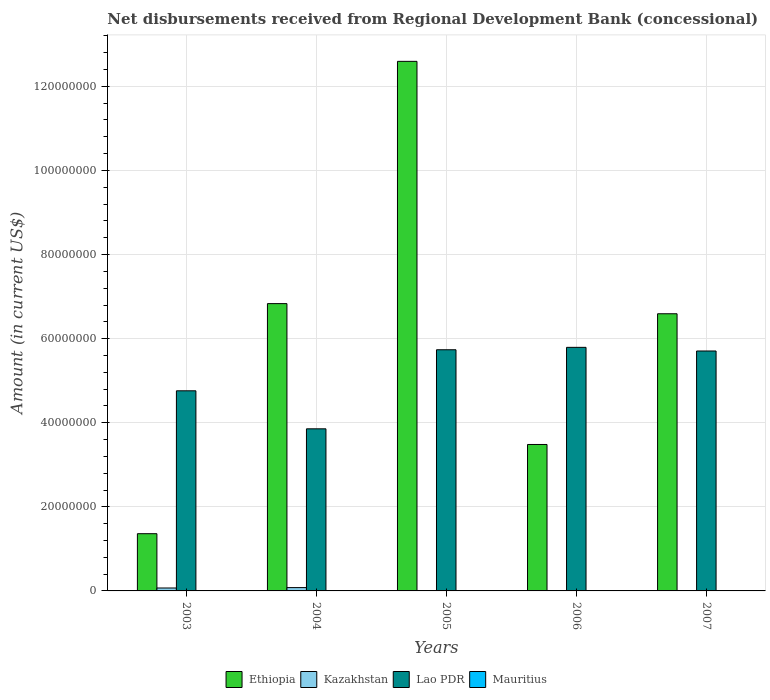How many groups of bars are there?
Provide a short and direct response. 5. Are the number of bars per tick equal to the number of legend labels?
Your answer should be very brief. No. How many bars are there on the 1st tick from the right?
Provide a succinct answer. 2. What is the label of the 2nd group of bars from the left?
Give a very brief answer. 2004. What is the amount of disbursements received from Regional Development Bank in Kazakhstan in 2005?
Your response must be concise. 9.50e+04. Across all years, what is the maximum amount of disbursements received from Regional Development Bank in Lao PDR?
Ensure brevity in your answer.  5.79e+07. Across all years, what is the minimum amount of disbursements received from Regional Development Bank in Lao PDR?
Provide a succinct answer. 3.86e+07. In which year was the amount of disbursements received from Regional Development Bank in Lao PDR maximum?
Your answer should be compact. 2006. What is the total amount of disbursements received from Regional Development Bank in Kazakhstan in the graph?
Offer a very short reply. 1.58e+06. What is the difference between the amount of disbursements received from Regional Development Bank in Lao PDR in 2003 and that in 2007?
Make the answer very short. -9.47e+06. What is the difference between the amount of disbursements received from Regional Development Bank in Mauritius in 2006 and the amount of disbursements received from Regional Development Bank in Lao PDR in 2004?
Your answer should be very brief. -3.86e+07. What is the average amount of disbursements received from Regional Development Bank in Ethiopia per year?
Make the answer very short. 6.17e+07. In the year 2003, what is the difference between the amount of disbursements received from Regional Development Bank in Ethiopia and amount of disbursements received from Regional Development Bank in Lao PDR?
Your answer should be compact. -3.40e+07. What is the ratio of the amount of disbursements received from Regional Development Bank in Kazakhstan in 2003 to that in 2005?
Offer a very short reply. 7.35. What is the difference between the highest and the second highest amount of disbursements received from Regional Development Bank in Ethiopia?
Offer a very short reply. 5.76e+07. What is the difference between the highest and the lowest amount of disbursements received from Regional Development Bank in Ethiopia?
Make the answer very short. 1.12e+08. In how many years, is the amount of disbursements received from Regional Development Bank in Mauritius greater than the average amount of disbursements received from Regional Development Bank in Mauritius taken over all years?
Your answer should be compact. 0. Are all the bars in the graph horizontal?
Provide a succinct answer. No. What is the difference between two consecutive major ticks on the Y-axis?
Provide a short and direct response. 2.00e+07. Are the values on the major ticks of Y-axis written in scientific E-notation?
Your answer should be compact. No. Does the graph contain grids?
Make the answer very short. Yes. How many legend labels are there?
Ensure brevity in your answer.  4. What is the title of the graph?
Your response must be concise. Net disbursements received from Regional Development Bank (concessional). Does "Namibia" appear as one of the legend labels in the graph?
Offer a very short reply. No. What is the label or title of the Y-axis?
Your answer should be very brief. Amount (in current US$). What is the Amount (in current US$) in Ethiopia in 2003?
Your response must be concise. 1.36e+07. What is the Amount (in current US$) of Kazakhstan in 2003?
Give a very brief answer. 6.98e+05. What is the Amount (in current US$) in Lao PDR in 2003?
Give a very brief answer. 4.76e+07. What is the Amount (in current US$) in Mauritius in 2003?
Provide a short and direct response. 0. What is the Amount (in current US$) of Ethiopia in 2004?
Make the answer very short. 6.83e+07. What is the Amount (in current US$) in Kazakhstan in 2004?
Offer a terse response. 7.91e+05. What is the Amount (in current US$) in Lao PDR in 2004?
Provide a succinct answer. 3.86e+07. What is the Amount (in current US$) in Mauritius in 2004?
Provide a succinct answer. 0. What is the Amount (in current US$) of Ethiopia in 2005?
Offer a very short reply. 1.26e+08. What is the Amount (in current US$) in Kazakhstan in 2005?
Ensure brevity in your answer.  9.50e+04. What is the Amount (in current US$) of Lao PDR in 2005?
Give a very brief answer. 5.74e+07. What is the Amount (in current US$) in Ethiopia in 2006?
Ensure brevity in your answer.  3.48e+07. What is the Amount (in current US$) of Lao PDR in 2006?
Your answer should be very brief. 5.79e+07. What is the Amount (in current US$) in Mauritius in 2006?
Provide a succinct answer. 0. What is the Amount (in current US$) in Ethiopia in 2007?
Provide a short and direct response. 6.59e+07. What is the Amount (in current US$) in Kazakhstan in 2007?
Your answer should be very brief. 0. What is the Amount (in current US$) in Lao PDR in 2007?
Offer a very short reply. 5.71e+07. What is the Amount (in current US$) of Mauritius in 2007?
Offer a terse response. 0. Across all years, what is the maximum Amount (in current US$) of Ethiopia?
Keep it short and to the point. 1.26e+08. Across all years, what is the maximum Amount (in current US$) in Kazakhstan?
Your answer should be very brief. 7.91e+05. Across all years, what is the maximum Amount (in current US$) in Lao PDR?
Give a very brief answer. 5.79e+07. Across all years, what is the minimum Amount (in current US$) in Ethiopia?
Offer a very short reply. 1.36e+07. Across all years, what is the minimum Amount (in current US$) in Kazakhstan?
Give a very brief answer. 0. Across all years, what is the minimum Amount (in current US$) of Lao PDR?
Keep it short and to the point. 3.86e+07. What is the total Amount (in current US$) in Ethiopia in the graph?
Make the answer very short. 3.09e+08. What is the total Amount (in current US$) of Kazakhstan in the graph?
Ensure brevity in your answer.  1.58e+06. What is the total Amount (in current US$) of Lao PDR in the graph?
Provide a succinct answer. 2.58e+08. What is the total Amount (in current US$) of Mauritius in the graph?
Your answer should be compact. 0. What is the difference between the Amount (in current US$) in Ethiopia in 2003 and that in 2004?
Provide a short and direct response. -5.47e+07. What is the difference between the Amount (in current US$) in Kazakhstan in 2003 and that in 2004?
Offer a very short reply. -9.30e+04. What is the difference between the Amount (in current US$) in Lao PDR in 2003 and that in 2004?
Give a very brief answer. 9.04e+06. What is the difference between the Amount (in current US$) in Ethiopia in 2003 and that in 2005?
Provide a short and direct response. -1.12e+08. What is the difference between the Amount (in current US$) in Kazakhstan in 2003 and that in 2005?
Offer a terse response. 6.03e+05. What is the difference between the Amount (in current US$) in Lao PDR in 2003 and that in 2005?
Give a very brief answer. -9.76e+06. What is the difference between the Amount (in current US$) in Ethiopia in 2003 and that in 2006?
Provide a short and direct response. -2.12e+07. What is the difference between the Amount (in current US$) of Lao PDR in 2003 and that in 2006?
Your answer should be compact. -1.03e+07. What is the difference between the Amount (in current US$) in Ethiopia in 2003 and that in 2007?
Provide a short and direct response. -5.23e+07. What is the difference between the Amount (in current US$) in Lao PDR in 2003 and that in 2007?
Provide a succinct answer. -9.47e+06. What is the difference between the Amount (in current US$) in Ethiopia in 2004 and that in 2005?
Provide a short and direct response. -5.76e+07. What is the difference between the Amount (in current US$) in Kazakhstan in 2004 and that in 2005?
Your answer should be very brief. 6.96e+05. What is the difference between the Amount (in current US$) in Lao PDR in 2004 and that in 2005?
Your answer should be very brief. -1.88e+07. What is the difference between the Amount (in current US$) in Ethiopia in 2004 and that in 2006?
Offer a terse response. 3.35e+07. What is the difference between the Amount (in current US$) of Lao PDR in 2004 and that in 2006?
Your answer should be very brief. -1.94e+07. What is the difference between the Amount (in current US$) in Ethiopia in 2004 and that in 2007?
Your answer should be compact. 2.41e+06. What is the difference between the Amount (in current US$) in Lao PDR in 2004 and that in 2007?
Give a very brief answer. -1.85e+07. What is the difference between the Amount (in current US$) of Ethiopia in 2005 and that in 2006?
Provide a succinct answer. 9.11e+07. What is the difference between the Amount (in current US$) in Lao PDR in 2005 and that in 2006?
Your answer should be compact. -5.73e+05. What is the difference between the Amount (in current US$) in Ethiopia in 2005 and that in 2007?
Offer a very short reply. 6.00e+07. What is the difference between the Amount (in current US$) in Lao PDR in 2005 and that in 2007?
Your response must be concise. 2.91e+05. What is the difference between the Amount (in current US$) of Ethiopia in 2006 and that in 2007?
Provide a short and direct response. -3.11e+07. What is the difference between the Amount (in current US$) of Lao PDR in 2006 and that in 2007?
Your answer should be compact. 8.64e+05. What is the difference between the Amount (in current US$) of Ethiopia in 2003 and the Amount (in current US$) of Kazakhstan in 2004?
Provide a short and direct response. 1.28e+07. What is the difference between the Amount (in current US$) of Ethiopia in 2003 and the Amount (in current US$) of Lao PDR in 2004?
Your response must be concise. -2.49e+07. What is the difference between the Amount (in current US$) of Kazakhstan in 2003 and the Amount (in current US$) of Lao PDR in 2004?
Offer a very short reply. -3.79e+07. What is the difference between the Amount (in current US$) of Ethiopia in 2003 and the Amount (in current US$) of Kazakhstan in 2005?
Your response must be concise. 1.35e+07. What is the difference between the Amount (in current US$) in Ethiopia in 2003 and the Amount (in current US$) in Lao PDR in 2005?
Provide a short and direct response. -4.37e+07. What is the difference between the Amount (in current US$) in Kazakhstan in 2003 and the Amount (in current US$) in Lao PDR in 2005?
Your answer should be compact. -5.67e+07. What is the difference between the Amount (in current US$) in Ethiopia in 2003 and the Amount (in current US$) in Lao PDR in 2006?
Your answer should be compact. -4.43e+07. What is the difference between the Amount (in current US$) in Kazakhstan in 2003 and the Amount (in current US$) in Lao PDR in 2006?
Your answer should be compact. -5.72e+07. What is the difference between the Amount (in current US$) in Ethiopia in 2003 and the Amount (in current US$) in Lao PDR in 2007?
Keep it short and to the point. -4.35e+07. What is the difference between the Amount (in current US$) in Kazakhstan in 2003 and the Amount (in current US$) in Lao PDR in 2007?
Offer a terse response. -5.64e+07. What is the difference between the Amount (in current US$) of Ethiopia in 2004 and the Amount (in current US$) of Kazakhstan in 2005?
Offer a terse response. 6.82e+07. What is the difference between the Amount (in current US$) of Ethiopia in 2004 and the Amount (in current US$) of Lao PDR in 2005?
Provide a succinct answer. 1.10e+07. What is the difference between the Amount (in current US$) in Kazakhstan in 2004 and the Amount (in current US$) in Lao PDR in 2005?
Give a very brief answer. -5.66e+07. What is the difference between the Amount (in current US$) in Ethiopia in 2004 and the Amount (in current US$) in Lao PDR in 2006?
Provide a succinct answer. 1.04e+07. What is the difference between the Amount (in current US$) in Kazakhstan in 2004 and the Amount (in current US$) in Lao PDR in 2006?
Keep it short and to the point. -5.71e+07. What is the difference between the Amount (in current US$) in Ethiopia in 2004 and the Amount (in current US$) in Lao PDR in 2007?
Offer a very short reply. 1.13e+07. What is the difference between the Amount (in current US$) of Kazakhstan in 2004 and the Amount (in current US$) of Lao PDR in 2007?
Give a very brief answer. -5.63e+07. What is the difference between the Amount (in current US$) of Ethiopia in 2005 and the Amount (in current US$) of Lao PDR in 2006?
Offer a very short reply. 6.80e+07. What is the difference between the Amount (in current US$) in Kazakhstan in 2005 and the Amount (in current US$) in Lao PDR in 2006?
Ensure brevity in your answer.  -5.78e+07. What is the difference between the Amount (in current US$) in Ethiopia in 2005 and the Amount (in current US$) in Lao PDR in 2007?
Your answer should be very brief. 6.89e+07. What is the difference between the Amount (in current US$) in Kazakhstan in 2005 and the Amount (in current US$) in Lao PDR in 2007?
Your answer should be very brief. -5.70e+07. What is the difference between the Amount (in current US$) in Ethiopia in 2006 and the Amount (in current US$) in Lao PDR in 2007?
Offer a very short reply. -2.22e+07. What is the average Amount (in current US$) of Ethiopia per year?
Your answer should be compact. 6.17e+07. What is the average Amount (in current US$) of Kazakhstan per year?
Your response must be concise. 3.17e+05. What is the average Amount (in current US$) in Lao PDR per year?
Give a very brief answer. 5.17e+07. What is the average Amount (in current US$) of Mauritius per year?
Your answer should be very brief. 0. In the year 2003, what is the difference between the Amount (in current US$) in Ethiopia and Amount (in current US$) in Kazakhstan?
Your answer should be compact. 1.29e+07. In the year 2003, what is the difference between the Amount (in current US$) of Ethiopia and Amount (in current US$) of Lao PDR?
Your answer should be very brief. -3.40e+07. In the year 2003, what is the difference between the Amount (in current US$) of Kazakhstan and Amount (in current US$) of Lao PDR?
Make the answer very short. -4.69e+07. In the year 2004, what is the difference between the Amount (in current US$) in Ethiopia and Amount (in current US$) in Kazakhstan?
Provide a short and direct response. 6.75e+07. In the year 2004, what is the difference between the Amount (in current US$) of Ethiopia and Amount (in current US$) of Lao PDR?
Keep it short and to the point. 2.98e+07. In the year 2004, what is the difference between the Amount (in current US$) in Kazakhstan and Amount (in current US$) in Lao PDR?
Provide a short and direct response. -3.78e+07. In the year 2005, what is the difference between the Amount (in current US$) in Ethiopia and Amount (in current US$) in Kazakhstan?
Give a very brief answer. 1.26e+08. In the year 2005, what is the difference between the Amount (in current US$) of Ethiopia and Amount (in current US$) of Lao PDR?
Make the answer very short. 6.86e+07. In the year 2005, what is the difference between the Amount (in current US$) in Kazakhstan and Amount (in current US$) in Lao PDR?
Ensure brevity in your answer.  -5.73e+07. In the year 2006, what is the difference between the Amount (in current US$) of Ethiopia and Amount (in current US$) of Lao PDR?
Provide a succinct answer. -2.31e+07. In the year 2007, what is the difference between the Amount (in current US$) in Ethiopia and Amount (in current US$) in Lao PDR?
Your answer should be compact. 8.85e+06. What is the ratio of the Amount (in current US$) of Ethiopia in 2003 to that in 2004?
Provide a short and direct response. 0.2. What is the ratio of the Amount (in current US$) in Kazakhstan in 2003 to that in 2004?
Offer a very short reply. 0.88. What is the ratio of the Amount (in current US$) of Lao PDR in 2003 to that in 2004?
Your response must be concise. 1.23. What is the ratio of the Amount (in current US$) in Ethiopia in 2003 to that in 2005?
Offer a terse response. 0.11. What is the ratio of the Amount (in current US$) in Kazakhstan in 2003 to that in 2005?
Make the answer very short. 7.35. What is the ratio of the Amount (in current US$) of Lao PDR in 2003 to that in 2005?
Provide a succinct answer. 0.83. What is the ratio of the Amount (in current US$) of Ethiopia in 2003 to that in 2006?
Your answer should be compact. 0.39. What is the ratio of the Amount (in current US$) in Lao PDR in 2003 to that in 2006?
Your answer should be compact. 0.82. What is the ratio of the Amount (in current US$) in Ethiopia in 2003 to that in 2007?
Make the answer very short. 0.21. What is the ratio of the Amount (in current US$) in Lao PDR in 2003 to that in 2007?
Keep it short and to the point. 0.83. What is the ratio of the Amount (in current US$) in Ethiopia in 2004 to that in 2005?
Provide a short and direct response. 0.54. What is the ratio of the Amount (in current US$) of Kazakhstan in 2004 to that in 2005?
Make the answer very short. 8.33. What is the ratio of the Amount (in current US$) of Lao PDR in 2004 to that in 2005?
Your response must be concise. 0.67. What is the ratio of the Amount (in current US$) of Ethiopia in 2004 to that in 2006?
Ensure brevity in your answer.  1.96. What is the ratio of the Amount (in current US$) in Lao PDR in 2004 to that in 2006?
Keep it short and to the point. 0.67. What is the ratio of the Amount (in current US$) in Ethiopia in 2004 to that in 2007?
Offer a terse response. 1.04. What is the ratio of the Amount (in current US$) in Lao PDR in 2004 to that in 2007?
Ensure brevity in your answer.  0.68. What is the ratio of the Amount (in current US$) of Ethiopia in 2005 to that in 2006?
Offer a very short reply. 3.62. What is the ratio of the Amount (in current US$) of Lao PDR in 2005 to that in 2006?
Offer a very short reply. 0.99. What is the ratio of the Amount (in current US$) in Ethiopia in 2005 to that in 2007?
Give a very brief answer. 1.91. What is the ratio of the Amount (in current US$) of Lao PDR in 2005 to that in 2007?
Ensure brevity in your answer.  1.01. What is the ratio of the Amount (in current US$) in Ethiopia in 2006 to that in 2007?
Provide a short and direct response. 0.53. What is the ratio of the Amount (in current US$) of Lao PDR in 2006 to that in 2007?
Keep it short and to the point. 1.02. What is the difference between the highest and the second highest Amount (in current US$) in Ethiopia?
Offer a terse response. 5.76e+07. What is the difference between the highest and the second highest Amount (in current US$) of Kazakhstan?
Give a very brief answer. 9.30e+04. What is the difference between the highest and the second highest Amount (in current US$) in Lao PDR?
Your response must be concise. 5.73e+05. What is the difference between the highest and the lowest Amount (in current US$) of Ethiopia?
Your response must be concise. 1.12e+08. What is the difference between the highest and the lowest Amount (in current US$) of Kazakhstan?
Give a very brief answer. 7.91e+05. What is the difference between the highest and the lowest Amount (in current US$) in Lao PDR?
Offer a very short reply. 1.94e+07. 